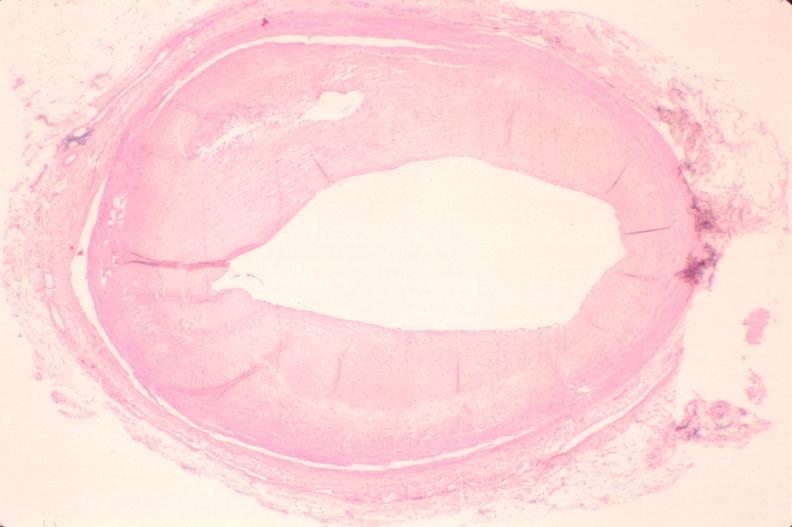what is atherosclerosis left?
Answer the question using a single word or phrase. Anterior descending coronary artery 